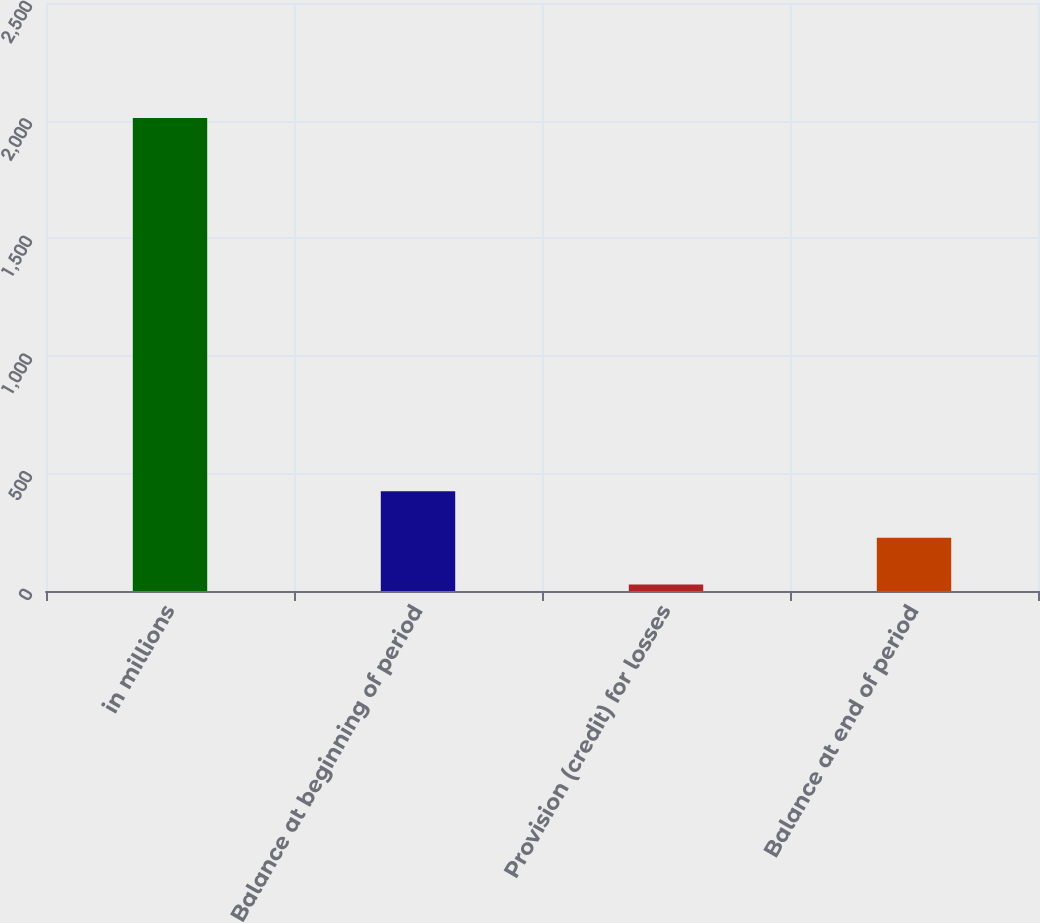Convert chart to OTSL. <chart><loc_0><loc_0><loc_500><loc_500><bar_chart><fcel>in millions<fcel>Balance at beginning of period<fcel>Provision (credit) for losses<fcel>Balance at end of period<nl><fcel>2011<fcel>424.6<fcel>28<fcel>226.3<nl></chart> 